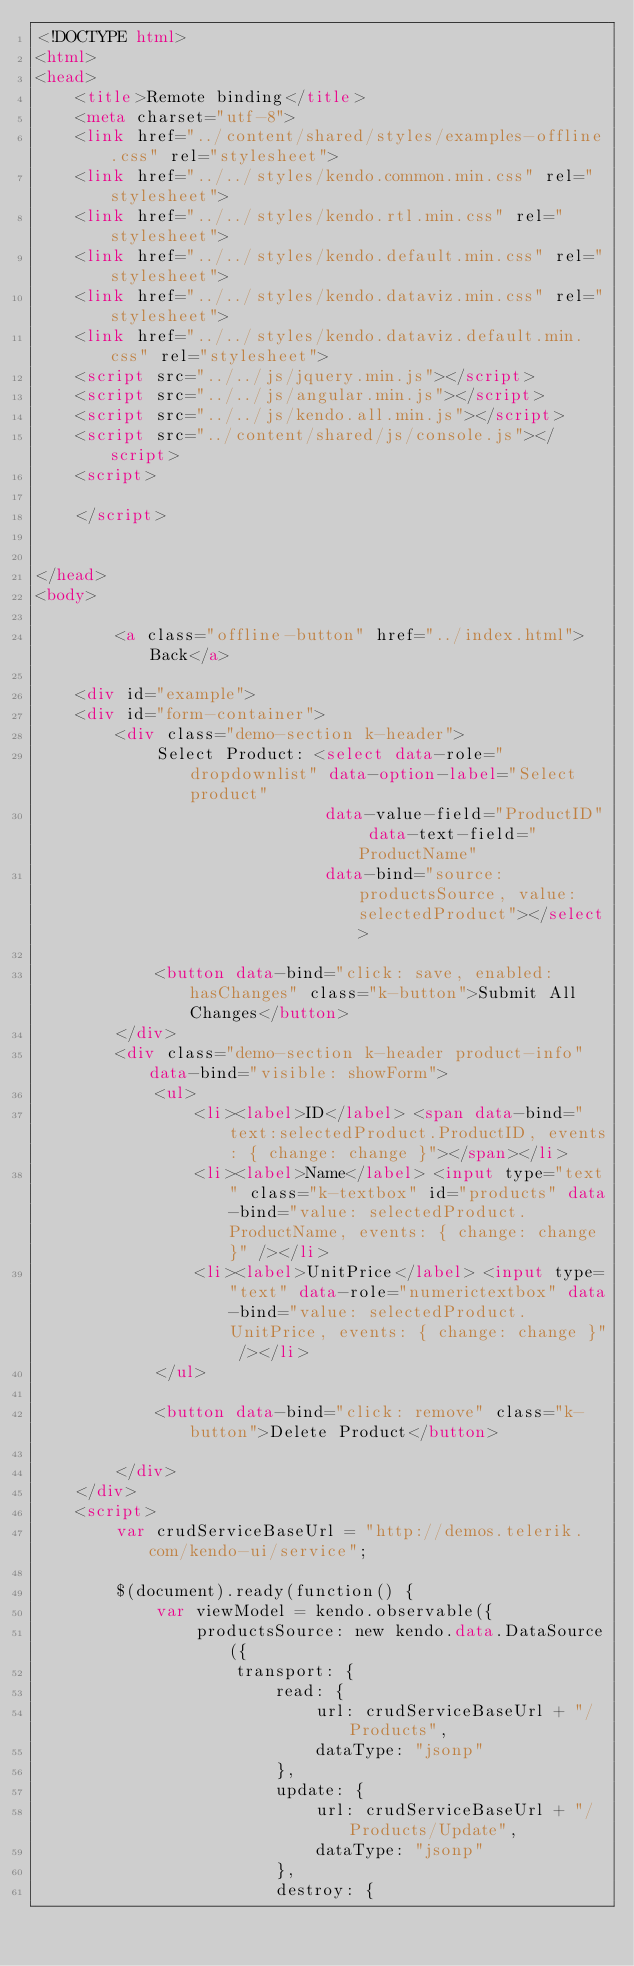Convert code to text. <code><loc_0><loc_0><loc_500><loc_500><_HTML_><!DOCTYPE html>
<html>
<head>
    <title>Remote binding</title>
    <meta charset="utf-8">
    <link href="../content/shared/styles/examples-offline.css" rel="stylesheet">
    <link href="../../styles/kendo.common.min.css" rel="stylesheet">
    <link href="../../styles/kendo.rtl.min.css" rel="stylesheet">
    <link href="../../styles/kendo.default.min.css" rel="stylesheet">
    <link href="../../styles/kendo.dataviz.min.css" rel="stylesheet">
    <link href="../../styles/kendo.dataviz.default.min.css" rel="stylesheet">
    <script src="../../js/jquery.min.js"></script>
    <script src="../../js/angular.min.js"></script>
    <script src="../../js/kendo.all.min.js"></script>
    <script src="../content/shared/js/console.js"></script>
    <script>
        
    </script>
    
    
</head>
<body>
    
        <a class="offline-button" href="../index.html">Back</a>
    
    <div id="example">
    <div id="form-container">
        <div class="demo-section k-header">
            Select Product: <select data-role="dropdownlist" data-option-label="Select product"
                             data-value-field="ProductID" data-text-field="ProductName"
                             data-bind="source: productsSource, value: selectedProduct"></select>

            <button data-bind="click: save, enabled: hasChanges" class="k-button">Submit All Changes</button>
        </div>
        <div class="demo-section k-header product-info" data-bind="visible: showForm">
            <ul>
                <li><label>ID</label> <span data-bind="text:selectedProduct.ProductID, events: { change: change }"></span></li>
                <li><label>Name</label> <input type="text" class="k-textbox" id="products" data-bind="value: selectedProduct.ProductName, events: { change: change }" /></li>
                <li><label>UnitPrice</label> <input type="text" data-role="numerictextbox" data-bind="value: selectedProduct.UnitPrice, events: { change: change }" /></li>
            </ul>

            <button data-bind="click: remove" class="k-button">Delete Product</button>

        </div>
    </div>
    <script>
        var crudServiceBaseUrl = "http://demos.telerik.com/kendo-ui/service";

        $(document).ready(function() {
            var viewModel = kendo.observable({
                productsSource: new kendo.data.DataSource({
                    transport: {
                        read: {
                            url: crudServiceBaseUrl + "/Products",
                            dataType: "jsonp"
                        },
                        update: {
                            url: crudServiceBaseUrl + "/Products/Update",
                            dataType: "jsonp"
                        },
                        destroy: {</code> 